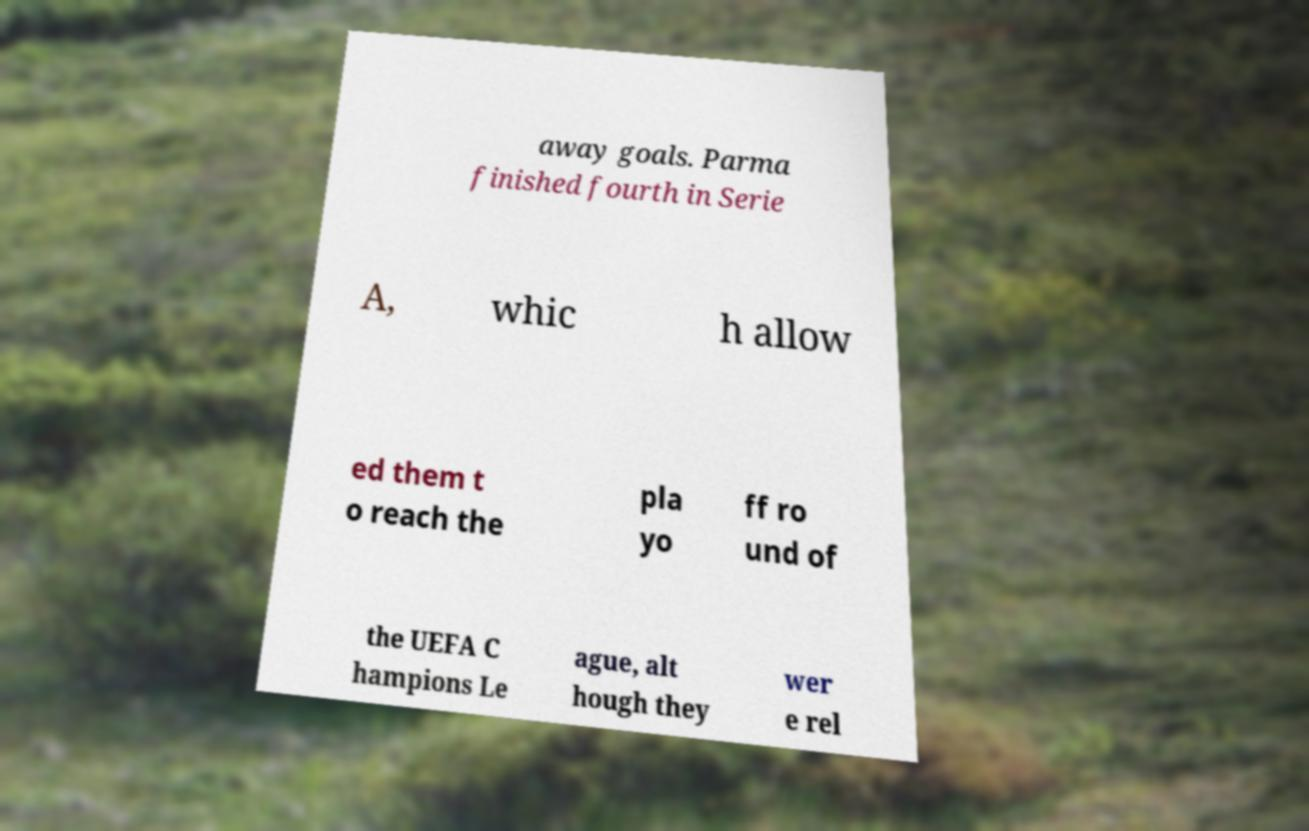There's text embedded in this image that I need extracted. Can you transcribe it verbatim? away goals. Parma finished fourth in Serie A, whic h allow ed them t o reach the pla yo ff ro und of the UEFA C hampions Le ague, alt hough they wer e rel 